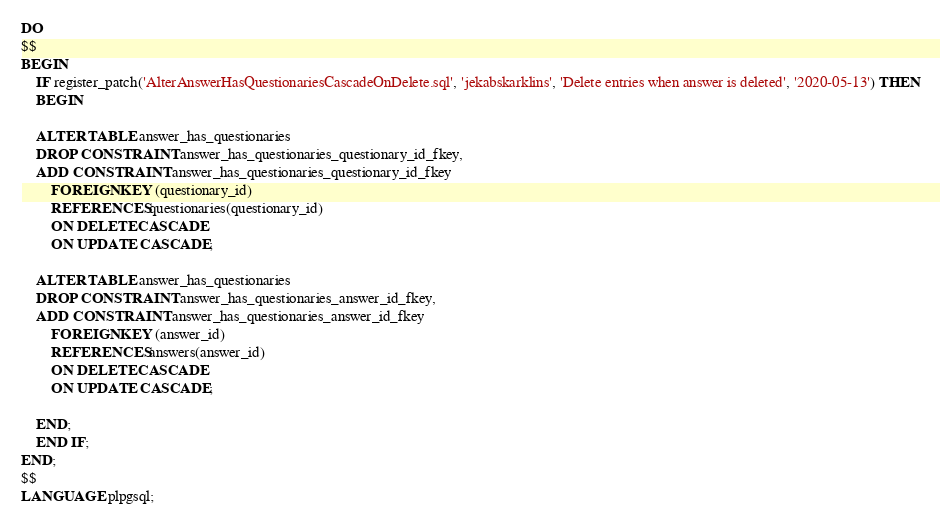<code> <loc_0><loc_0><loc_500><loc_500><_SQL_>DO
$$
BEGIN
	IF register_patch('AlterAnswerHasQuestionariesCascadeOnDelete.sql', 'jekabskarklins', 'Delete entries when answer is deleted', '2020-05-13') THEN
	BEGIN

	ALTER TABLE answer_has_questionaries
	DROP CONSTRAINT answer_has_questionaries_questionary_id_fkey,
	ADD CONSTRAINT answer_has_questionaries_questionary_id_fkey
		FOREIGN KEY (questionary_id)
		REFERENCES questionaries(questionary_id)
		ON DELETE CASCADE
		ON UPDATE CASCADE;

	ALTER TABLE answer_has_questionaries
	DROP CONSTRAINT answer_has_questionaries_answer_id_fkey,
	ADD CONSTRAINT answer_has_questionaries_answer_id_fkey
		FOREIGN KEY (answer_id)
		REFERENCES answers(answer_id)
		ON DELETE CASCADE
		ON UPDATE CASCADE;

    END;
	END IF;
END;
$$
LANGUAGE plpgsql;
</code> 